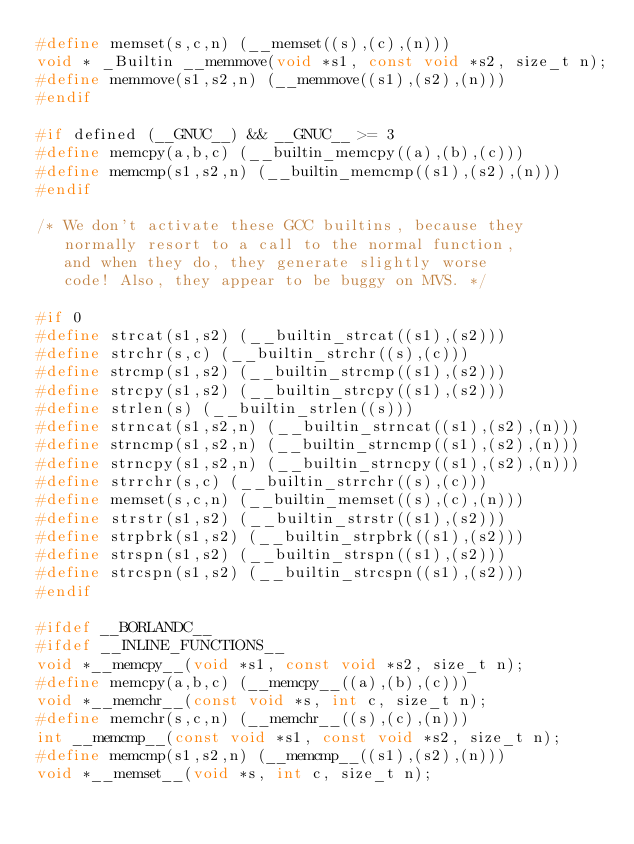Convert code to text. <code><loc_0><loc_0><loc_500><loc_500><_C_>#define memset(s,c,n) (__memset((s),(c),(n)))
void * _Builtin __memmove(void *s1, const void *s2, size_t n);
#define memmove(s1,s2,n) (__memmove((s1),(s2),(n)))
#endif

#if defined (__GNUC__) && __GNUC__ >= 3
#define memcpy(a,b,c) (__builtin_memcpy((a),(b),(c)))
#define memcmp(s1,s2,n) (__builtin_memcmp((s1),(s2),(n)))
#endif

/* We don't activate these GCC builtins, because they
   normally resort to a call to the normal function,
   and when they do, they generate slightly worse
   code! Also, they appear to be buggy on MVS. */

#if 0
#define strcat(s1,s2) (__builtin_strcat((s1),(s2)))
#define strchr(s,c) (__builtin_strchr((s),(c)))
#define strcmp(s1,s2) (__builtin_strcmp((s1),(s2)))
#define strcpy(s1,s2) (__builtin_strcpy((s1),(s2)))
#define strlen(s) (__builtin_strlen((s)))
#define strncat(s1,s2,n) (__builtin_strncat((s1),(s2),(n)))
#define strncmp(s1,s2,n) (__builtin_strncmp((s1),(s2),(n)))
#define strncpy(s1,s2,n) (__builtin_strncpy((s1),(s2),(n)))
#define strrchr(s,c) (__builtin_strrchr((s),(c)))
#define memset(s,c,n) (__builtin_memset((s),(c),(n)))
#define strstr(s1,s2) (__builtin_strstr((s1),(s2)))
#define strpbrk(s1,s2) (__builtin_strpbrk((s1),(s2)))
#define strspn(s1,s2) (__builtin_strspn((s1),(s2)))
#define strcspn(s1,s2) (__builtin_strcspn((s1),(s2)))
#endif

#ifdef __BORLANDC__
#ifdef __INLINE_FUNCTIONS__
void *__memcpy__(void *s1, const void *s2, size_t n);
#define memcpy(a,b,c) (__memcpy__((a),(b),(c)))
void *__memchr__(const void *s, int c, size_t n);
#define memchr(s,c,n) (__memchr__((s),(c),(n)))
int __memcmp__(const void *s1, const void *s2, size_t n);
#define memcmp(s1,s2,n) (__memcmp__((s1),(s2),(n)))
void *__memset__(void *s, int c, size_t n);</code> 